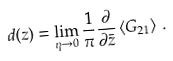Convert formula to latex. <formula><loc_0><loc_0><loc_500><loc_500>d ( z ) = \lim _ { \eta \rightarrow 0 } \frac { 1 } { \pi } \frac { \partial } { \partial \bar { z } } \left \langle G _ { 2 1 } \right \rangle \, .</formula> 